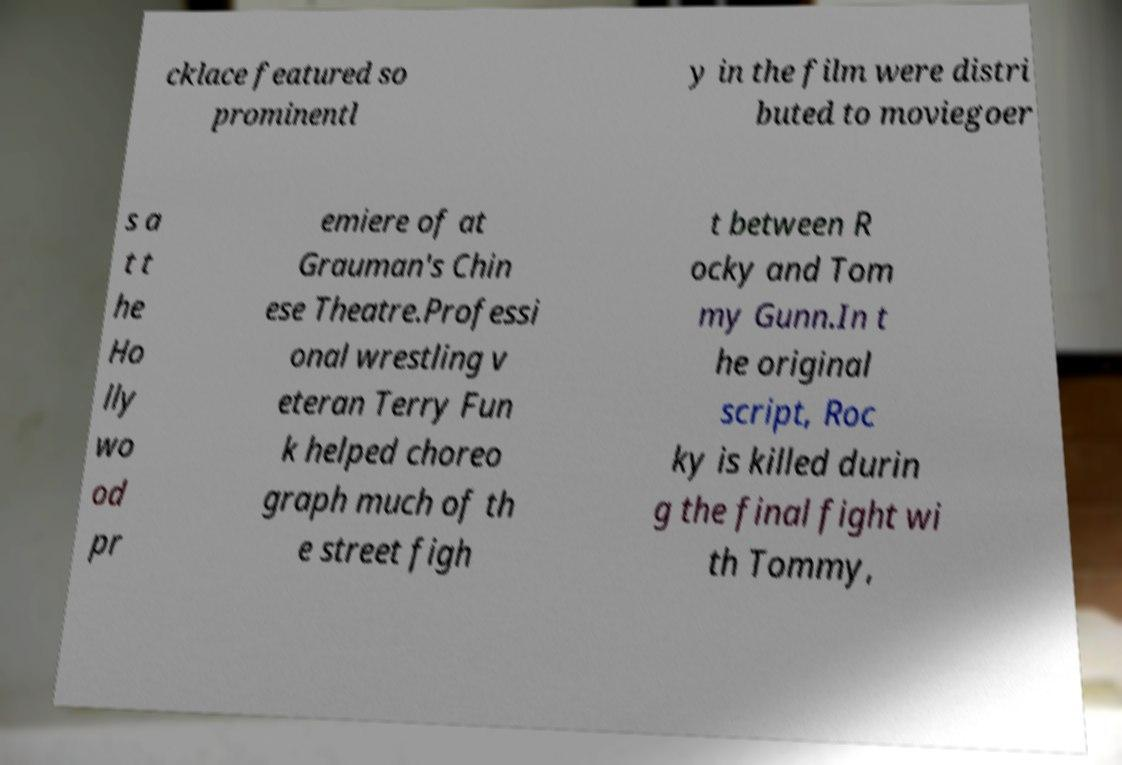What messages or text are displayed in this image? I need them in a readable, typed format. cklace featured so prominentl y in the film were distri buted to moviegoer s a t t he Ho lly wo od pr emiere of at Grauman's Chin ese Theatre.Professi onal wrestling v eteran Terry Fun k helped choreo graph much of th e street figh t between R ocky and Tom my Gunn.In t he original script, Roc ky is killed durin g the final fight wi th Tommy, 